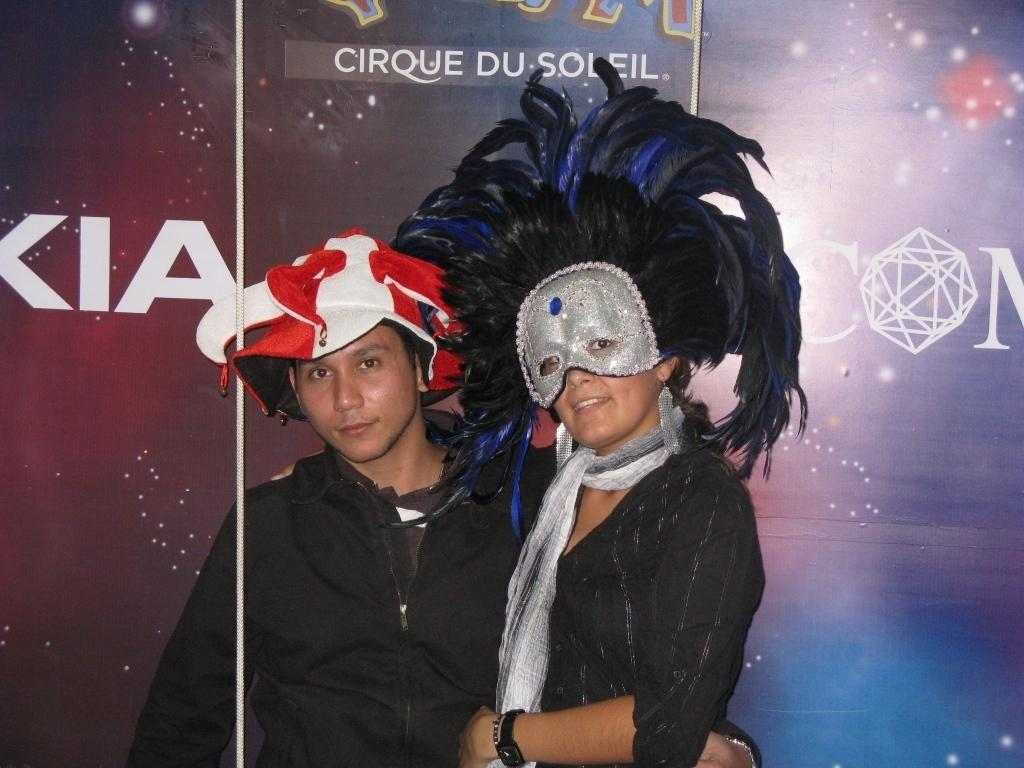What is the man wearing on his head in the image? The man is wearing a cap in the image. What is the woman wearing on her face in the image? The woman is wearing a face mask in the image. Can you describe the banner in the background of the image? There is a banner with text in the background of the image. How many ghosts can be seen interacting with the pipe in the image? There are no ghosts or pipes present in the image. What type of boats are visible in the image? There are no boats present in the image. 